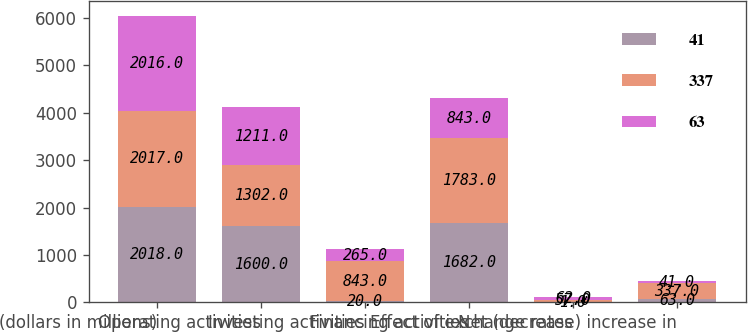Convert chart. <chart><loc_0><loc_0><loc_500><loc_500><stacked_bar_chart><ecel><fcel>(dollars in millions)<fcel>Operating activities<fcel>Investing activities<fcel>Financing activities<fcel>Effect of exchange rates<fcel>Net (decrease) increase in<nl><fcel>41<fcel>2018<fcel>1600<fcel>20<fcel>1682<fcel>1<fcel>63<nl><fcel>337<fcel>2017<fcel>1302<fcel>843<fcel>1783<fcel>57<fcel>337<nl><fcel>63<fcel>2016<fcel>1211<fcel>265<fcel>843<fcel>62<fcel>41<nl></chart> 